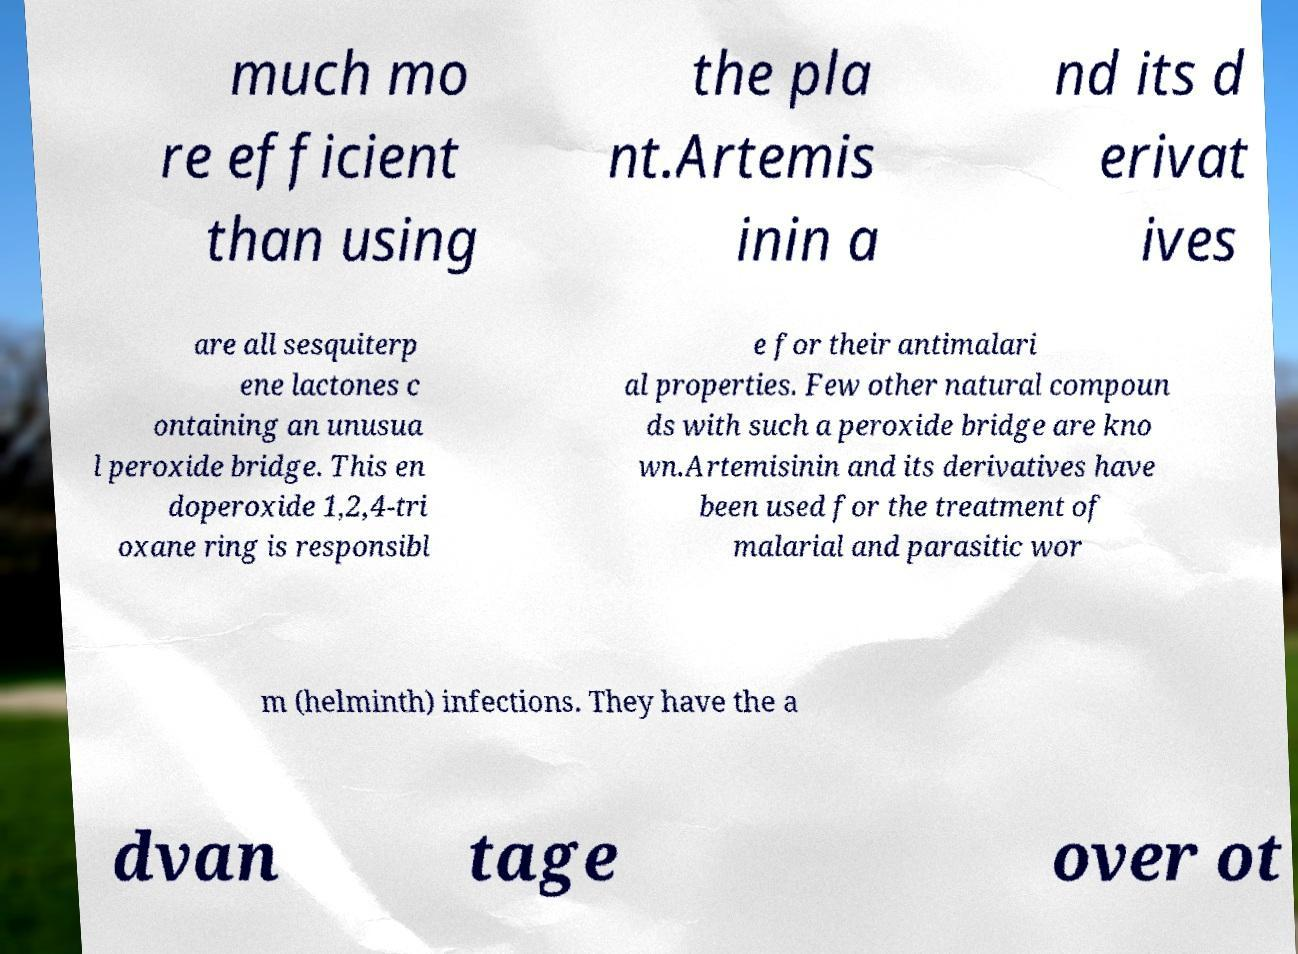Can you read and provide the text displayed in the image?This photo seems to have some interesting text. Can you extract and type it out for me? much mo re efficient than using the pla nt.Artemis inin a nd its d erivat ives are all sesquiterp ene lactones c ontaining an unusua l peroxide bridge. This en doperoxide 1,2,4-tri oxane ring is responsibl e for their antimalari al properties. Few other natural compoun ds with such a peroxide bridge are kno wn.Artemisinin and its derivatives have been used for the treatment of malarial and parasitic wor m (helminth) infections. They have the a dvan tage over ot 